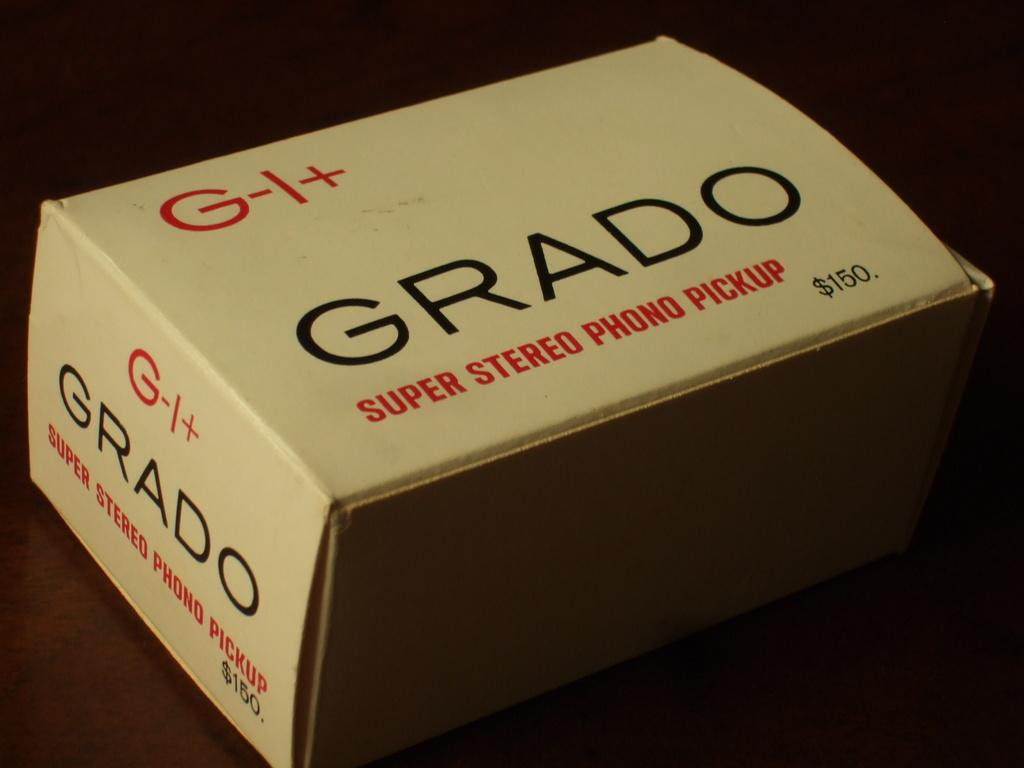What kind of audio product is in the box?
Give a very brief answer. Super stereo phono pickup. 